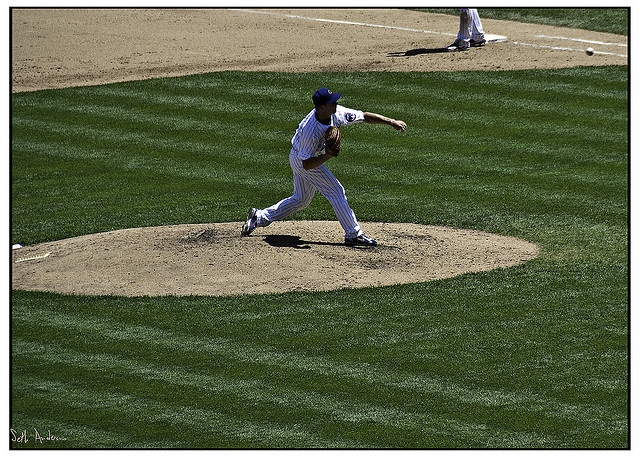Describe the objects in this image and their specific colors. I can see people in white, black, gray, and navy tones, people in white, black, gray, lavender, and darkgray tones, baseball glove in white, black, darkgreen, maroon, and gray tones, and sports ball in white, black, darkgray, and gray tones in this image. 